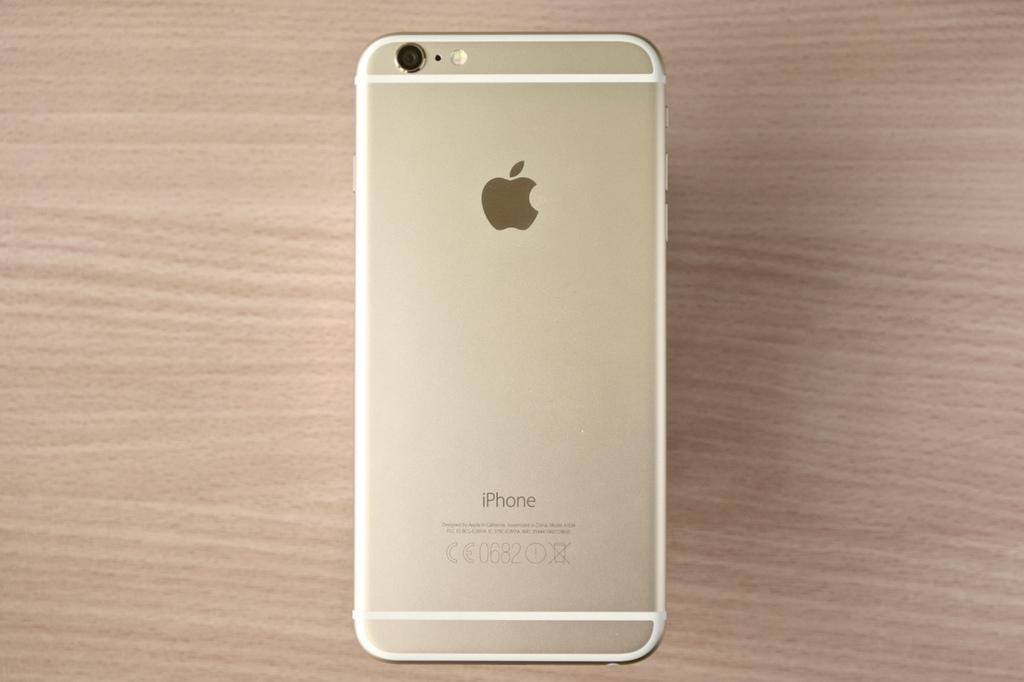<image>
Relay a brief, clear account of the picture shown. The iPhone was designed in California and made in China. 